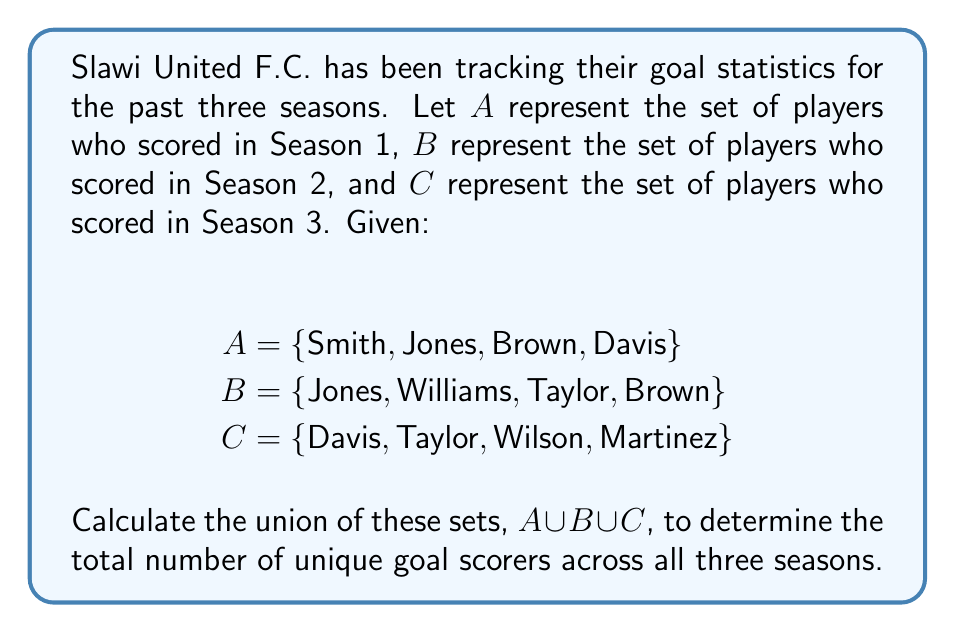Could you help me with this problem? To solve this problem, we need to find the union of sets $A$, $B$, and $C$. The union of sets includes all unique elements from all sets involved.

Let's approach this step-by-step:

1. First, let's combine sets $A$ and $B$:
   $A \cup B = \{Smith, Jones, Brown, Davis, Williams, Taylor\}$

2. Now, let's add set $C$ to this result:
   $(A \cup B) \cup C = \{Smith, Jones, Brown, Davis, Williams, Taylor, Wilson, Martinez\}$

3. To ensure we haven't missed any elements or included any duplicates, let's cross-check each player:
   - Smith: in $A$ only
   - Jones: in $A$ and $B$
   - Brown: in $A$ and $B$
   - Davis: in $A$ and $C$
   - Williams: in $B$ only
   - Taylor: in $B$ and $C$
   - Wilson: in $C$ only
   - Martinez: in $C$ only

4. Count the unique elements in the final set:
   $|A \cup B \cup C| = 8$

Therefore, there are 8 unique goal scorers across all three seasons for Slawi United F.C.
Answer: $A \cup B \cup C = \{Smith, Jones, Brown, Davis, Williams, Taylor, Wilson, Martinez\}$

The number of unique goal scorers is 8. 